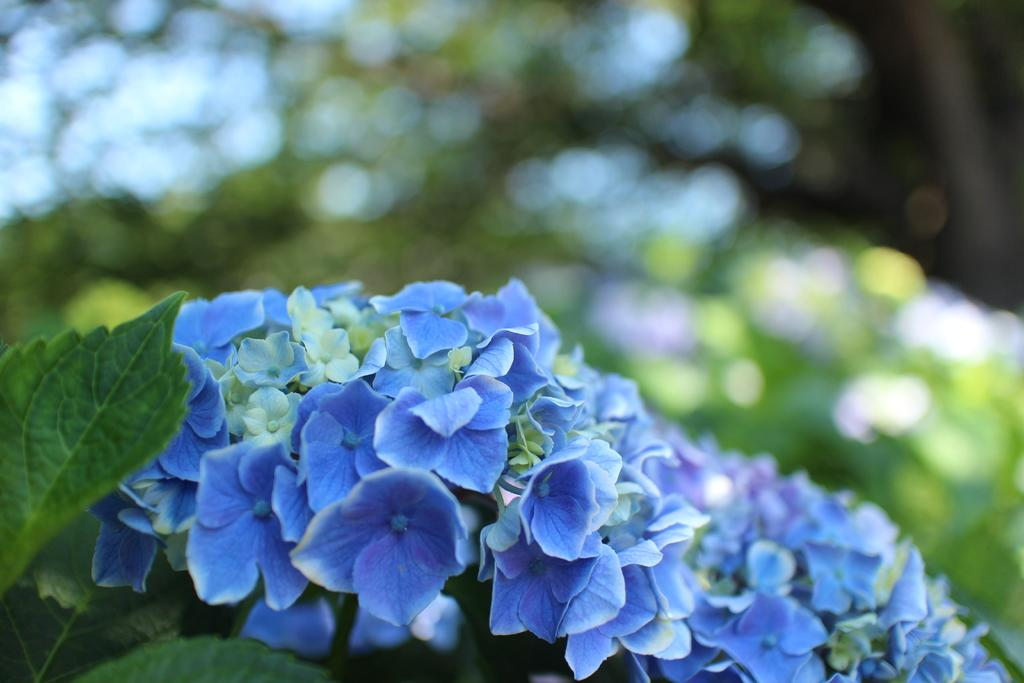What type of flora can be seen in the image? There are flowers in the image. What colors are the flowers? The flowers are blue and white in color. What else is present in the image besides the flowers? Leaves are present in the image. How would you describe the background of the image? The background of the image is blurred. What type of apparel is the owl wearing in the image? There is no owl present in the image, and therefore no apparel can be observed. 